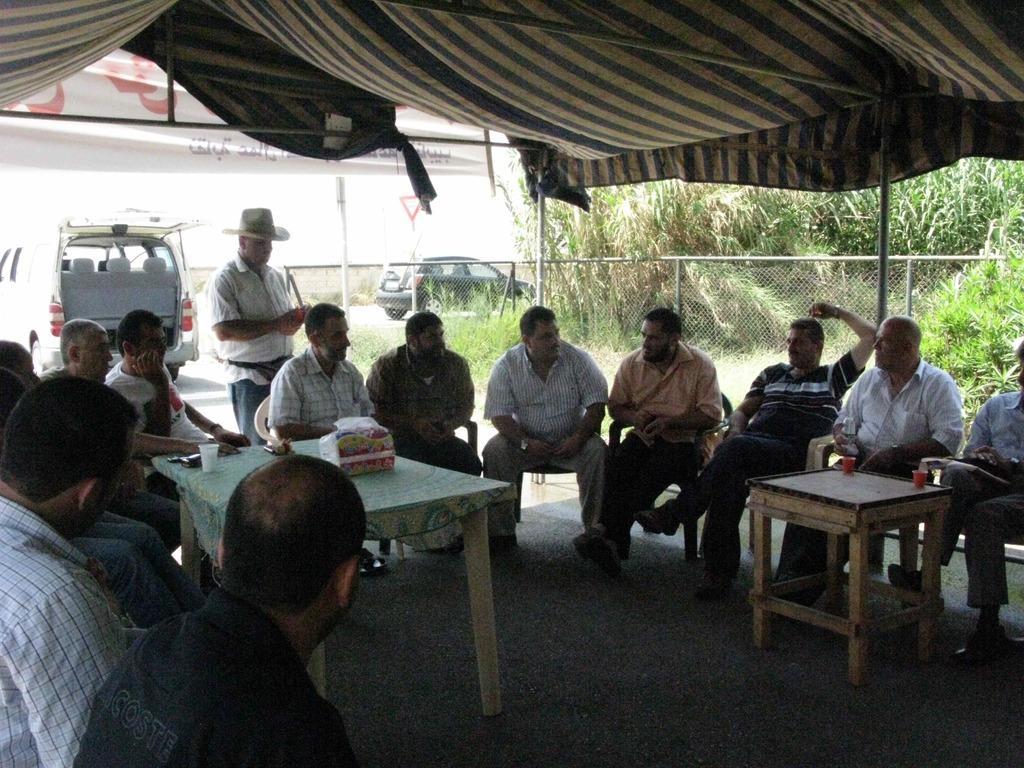Can you describe this image briefly? Here we can see a group of people sitting on chairs with a couple of tables in front of them having cups and something on it and behind them there is a man standing and he is wearing a hat and there are cars present and there is a fencing, these are all sitting under a tent and there are plants present 